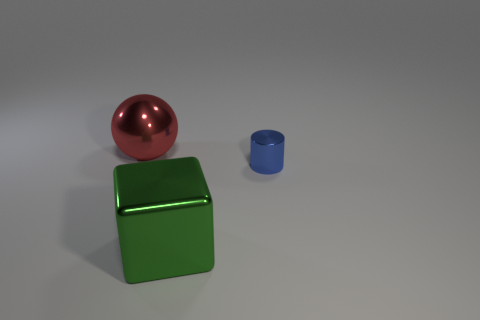Add 1 green metal blocks. How many objects exist? 4 Subtract all balls. How many objects are left? 2 Add 1 small metal things. How many small metal things exist? 2 Subtract 0 blue balls. How many objects are left? 3 Subtract all tiny blue objects. Subtract all metallic blocks. How many objects are left? 1 Add 2 red shiny balls. How many red shiny balls are left? 3 